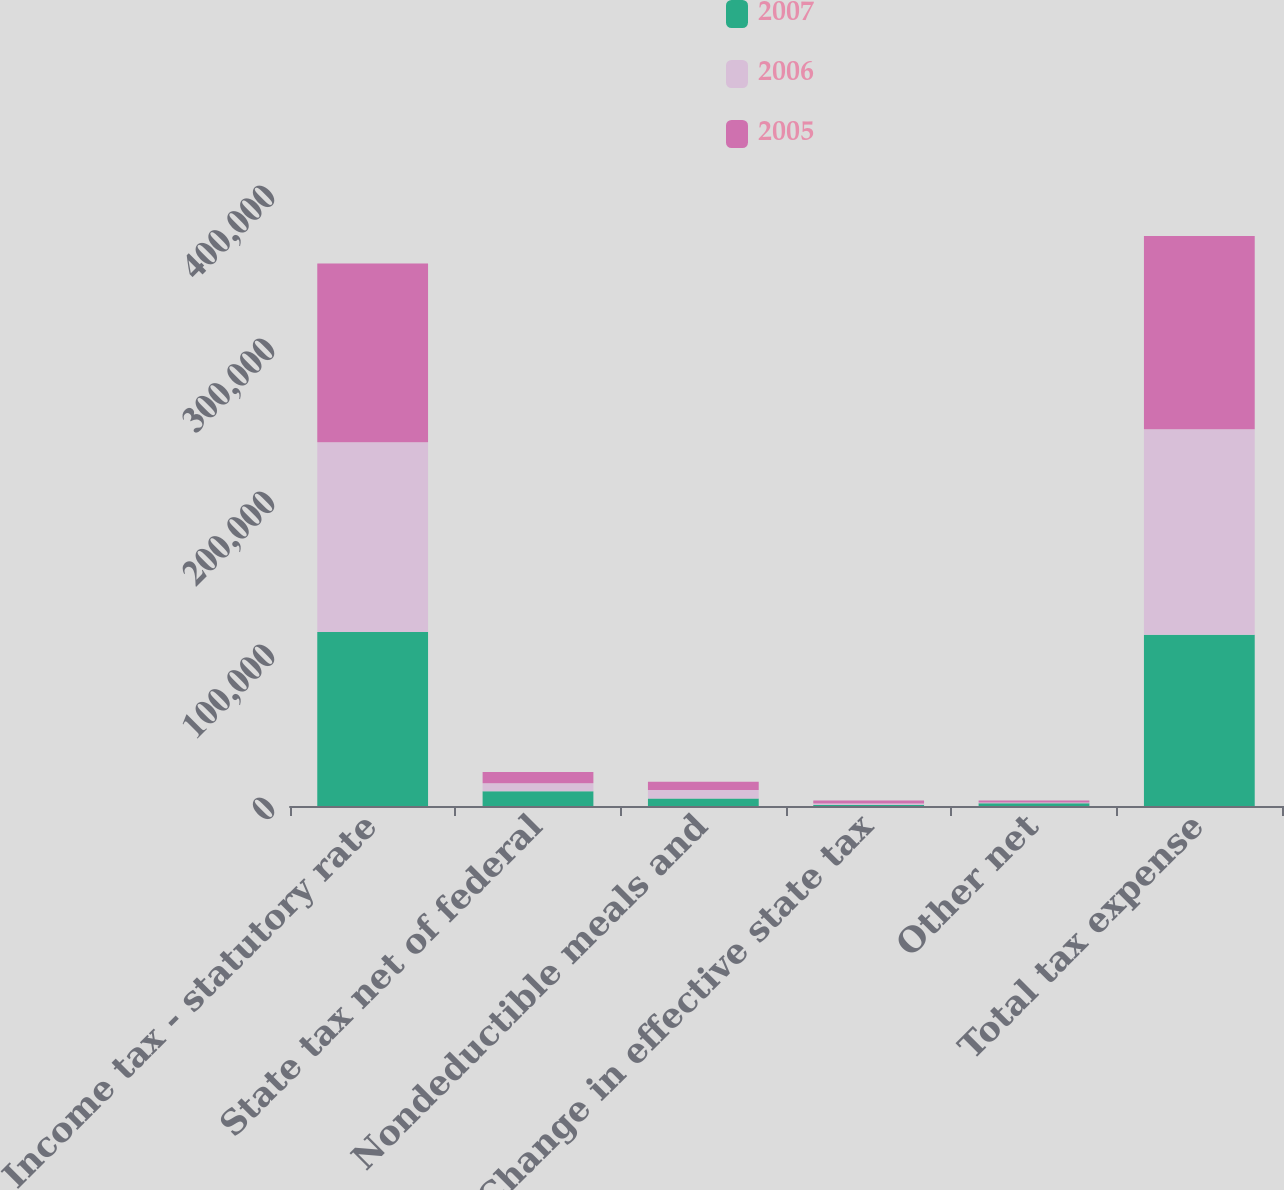<chart> <loc_0><loc_0><loc_500><loc_500><stacked_bar_chart><ecel><fcel>Income tax - statutory rate<fcel>State tax net of federal<fcel>Nondeductible meals and<fcel>Change in effective state tax<fcel>Other net<fcel>Total tax expense<nl><fcel>2007<fcel>113766<fcel>9569<fcel>4828<fcel>714<fcel>1858<fcel>111913<nl><fcel>2006<fcel>124009<fcel>5232<fcel>5691<fcel>932<fcel>361<fcel>134361<nl><fcel>2005<fcel>116769<fcel>7492<fcel>5380<fcel>1914<fcel>1412<fcel>126315<nl></chart> 